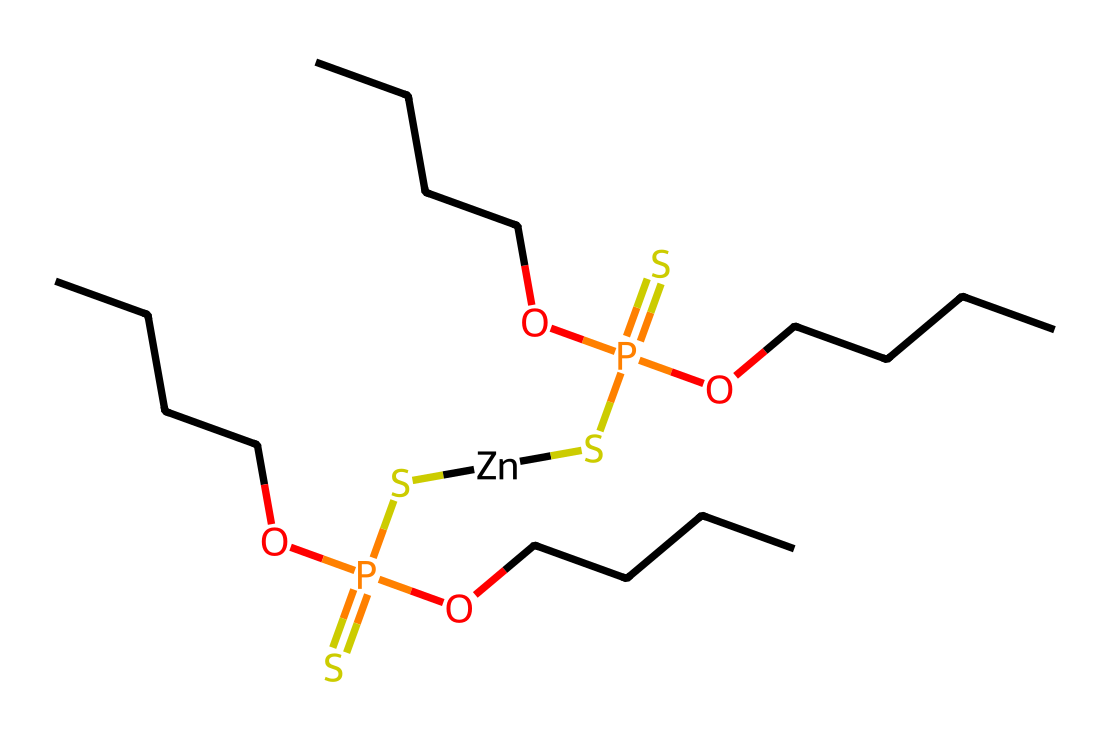What is the total number of phosphorus atoms in this chemical structure? The chemical structure contains two phosphorous atoms, as indicated by the "P" in the SMILES.
Answer: 2 How many sulfur atoms are present? In the structure, there are two sulfur atoms highlighted by the "S" in the SMILES.
Answer: 2 How many ethyl groups (CCCC) are attached to the phosphorus atoms? The chemical indicates four ethyl groups (represented as "OCCCC" next to each phosphorus atom), showing that each phosphorus has one ethyl group attached.
Answer: 4 Is this chemical capable of geometric isomerism? The presence of two different groups on either side of the sulfur and phosphorus indicates potential cis-trans isomerism, allowing for different spatial arrangements.
Answer: Yes What role does zinc play in this structure? Zinc is represented by "[Zn]," suggesting it acts as a coordination center or catalyst for the reactions involving the additives in motor oil.
Answer: Catalyst Explain if the presence of sulfur creates chirality in this molecule. The sulfur atoms do not create chiral centers on their own, as they are symmetrically placed within the structure without any arrangement of substituents that would lead to stereoisomers.
Answer: No What type of bonds connect the phosphorus and sulfur atoms? The connections between phosphorus and sulfur atoms are phospho-sulfide bonds, suggesting a common interaction in organophosphorus chemistry.
Answer: Phospho-sulfide bonds 